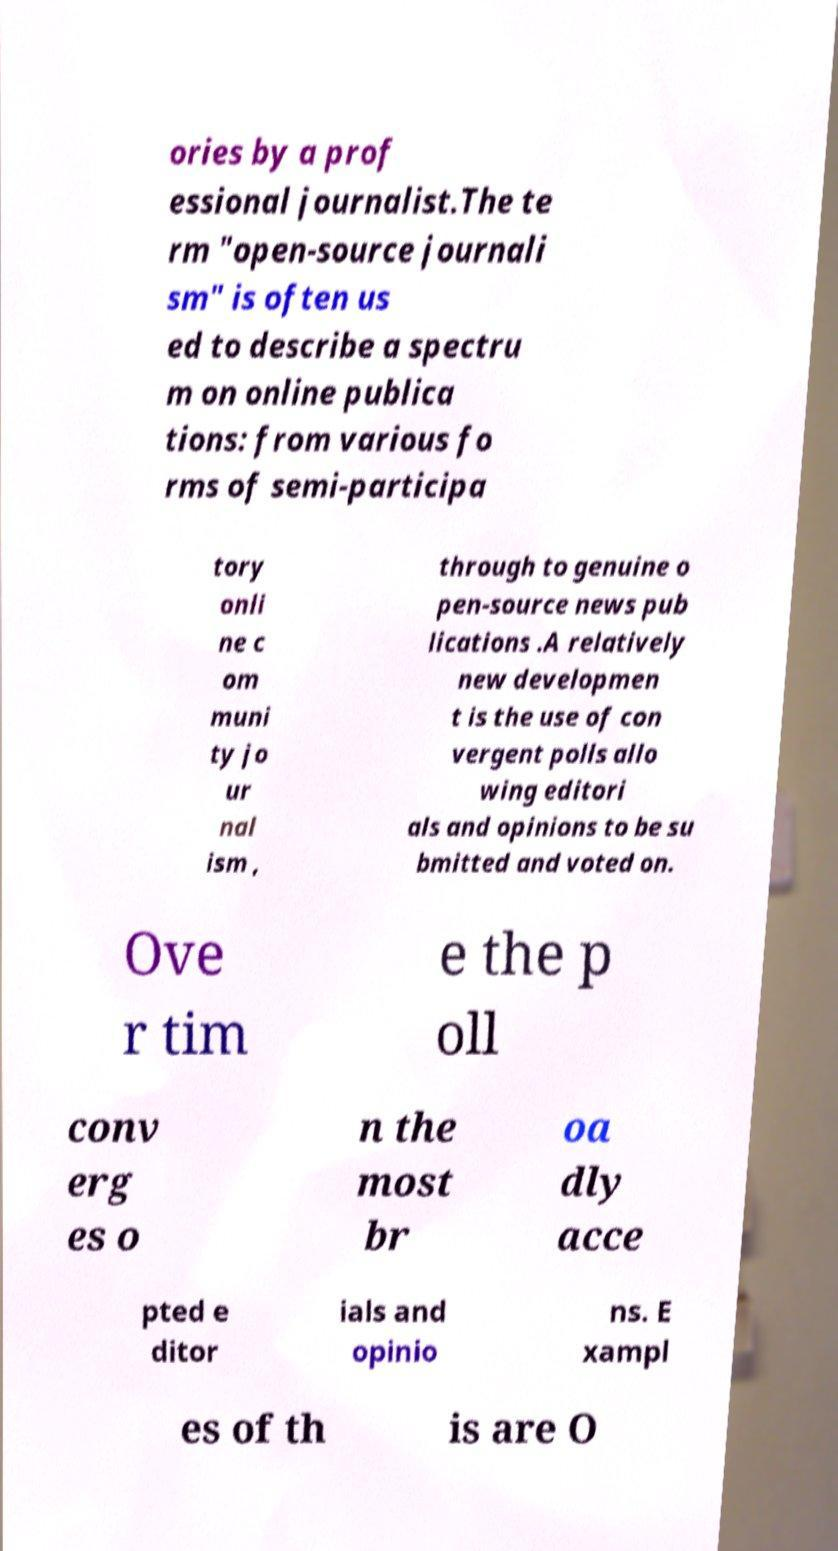Can you accurately transcribe the text from the provided image for me? ories by a prof essional journalist.The te rm "open-source journali sm" is often us ed to describe a spectru m on online publica tions: from various fo rms of semi-participa tory onli ne c om muni ty jo ur nal ism , through to genuine o pen-source news pub lications .A relatively new developmen t is the use of con vergent polls allo wing editori als and opinions to be su bmitted and voted on. Ove r tim e the p oll conv erg es o n the most br oa dly acce pted e ditor ials and opinio ns. E xampl es of th is are O 